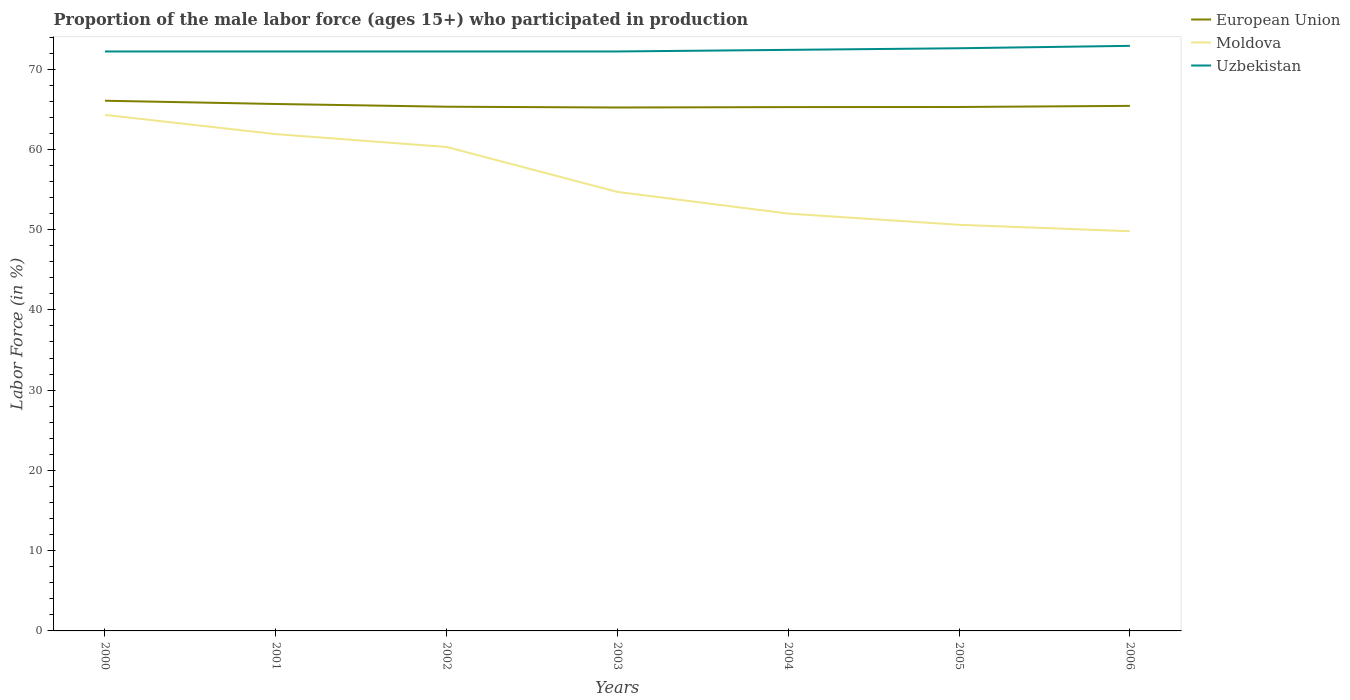How many different coloured lines are there?
Your answer should be very brief. 3. Does the line corresponding to European Union intersect with the line corresponding to Uzbekistan?
Ensure brevity in your answer.  No. Across all years, what is the maximum proportion of the male labor force who participated in production in Moldova?
Your answer should be very brief. 49.8. In which year was the proportion of the male labor force who participated in production in Moldova maximum?
Keep it short and to the point. 2006. What is the total proportion of the male labor force who participated in production in European Union in the graph?
Keep it short and to the point. 0.24. What is the difference between the highest and the second highest proportion of the male labor force who participated in production in Moldova?
Your response must be concise. 14.5. What is the difference between the highest and the lowest proportion of the male labor force who participated in production in Moldova?
Your response must be concise. 3. Is the proportion of the male labor force who participated in production in Moldova strictly greater than the proportion of the male labor force who participated in production in Uzbekistan over the years?
Offer a terse response. Yes. How many lines are there?
Keep it short and to the point. 3. Are the values on the major ticks of Y-axis written in scientific E-notation?
Offer a very short reply. No. Does the graph contain any zero values?
Your answer should be compact. No. How are the legend labels stacked?
Your answer should be compact. Vertical. What is the title of the graph?
Keep it short and to the point. Proportion of the male labor force (ages 15+) who participated in production. What is the Labor Force (in %) in European Union in 2000?
Your answer should be very brief. 66.06. What is the Labor Force (in %) in Moldova in 2000?
Offer a very short reply. 64.3. What is the Labor Force (in %) of Uzbekistan in 2000?
Provide a short and direct response. 72.2. What is the Labor Force (in %) of European Union in 2001?
Offer a terse response. 65.66. What is the Labor Force (in %) in Moldova in 2001?
Your answer should be very brief. 61.9. What is the Labor Force (in %) in Uzbekistan in 2001?
Your answer should be compact. 72.2. What is the Labor Force (in %) in European Union in 2002?
Make the answer very short. 65.31. What is the Labor Force (in %) in Moldova in 2002?
Your answer should be compact. 60.3. What is the Labor Force (in %) in Uzbekistan in 2002?
Ensure brevity in your answer.  72.2. What is the Labor Force (in %) in European Union in 2003?
Keep it short and to the point. 65.22. What is the Labor Force (in %) of Moldova in 2003?
Your answer should be very brief. 54.7. What is the Labor Force (in %) in Uzbekistan in 2003?
Provide a short and direct response. 72.2. What is the Labor Force (in %) of European Union in 2004?
Your answer should be very brief. 65.27. What is the Labor Force (in %) in Uzbekistan in 2004?
Keep it short and to the point. 72.4. What is the Labor Force (in %) of European Union in 2005?
Your answer should be compact. 65.28. What is the Labor Force (in %) in Moldova in 2005?
Your answer should be compact. 50.6. What is the Labor Force (in %) in Uzbekistan in 2005?
Give a very brief answer. 72.6. What is the Labor Force (in %) in European Union in 2006?
Make the answer very short. 65.42. What is the Labor Force (in %) in Moldova in 2006?
Make the answer very short. 49.8. What is the Labor Force (in %) in Uzbekistan in 2006?
Your answer should be very brief. 72.9. Across all years, what is the maximum Labor Force (in %) of European Union?
Give a very brief answer. 66.06. Across all years, what is the maximum Labor Force (in %) of Moldova?
Offer a terse response. 64.3. Across all years, what is the maximum Labor Force (in %) in Uzbekistan?
Give a very brief answer. 72.9. Across all years, what is the minimum Labor Force (in %) of European Union?
Keep it short and to the point. 65.22. Across all years, what is the minimum Labor Force (in %) in Moldova?
Give a very brief answer. 49.8. Across all years, what is the minimum Labor Force (in %) in Uzbekistan?
Your answer should be very brief. 72.2. What is the total Labor Force (in %) in European Union in the graph?
Offer a terse response. 458.22. What is the total Labor Force (in %) of Moldova in the graph?
Keep it short and to the point. 393.6. What is the total Labor Force (in %) in Uzbekistan in the graph?
Provide a short and direct response. 506.7. What is the difference between the Labor Force (in %) of European Union in 2000 and that in 2001?
Provide a succinct answer. 0.41. What is the difference between the Labor Force (in %) in Moldova in 2000 and that in 2001?
Offer a very short reply. 2.4. What is the difference between the Labor Force (in %) of Uzbekistan in 2000 and that in 2001?
Give a very brief answer. 0. What is the difference between the Labor Force (in %) of European Union in 2000 and that in 2002?
Provide a short and direct response. 0.75. What is the difference between the Labor Force (in %) in Uzbekistan in 2000 and that in 2002?
Provide a succinct answer. 0. What is the difference between the Labor Force (in %) in European Union in 2000 and that in 2003?
Your response must be concise. 0.84. What is the difference between the Labor Force (in %) in Uzbekistan in 2000 and that in 2003?
Give a very brief answer. 0. What is the difference between the Labor Force (in %) in European Union in 2000 and that in 2004?
Provide a succinct answer. 0.79. What is the difference between the Labor Force (in %) of European Union in 2000 and that in 2005?
Offer a terse response. 0.78. What is the difference between the Labor Force (in %) of Uzbekistan in 2000 and that in 2005?
Give a very brief answer. -0.4. What is the difference between the Labor Force (in %) of European Union in 2000 and that in 2006?
Give a very brief answer. 0.64. What is the difference between the Labor Force (in %) of Uzbekistan in 2000 and that in 2006?
Offer a terse response. -0.7. What is the difference between the Labor Force (in %) of European Union in 2001 and that in 2002?
Provide a succinct answer. 0.34. What is the difference between the Labor Force (in %) in Moldova in 2001 and that in 2002?
Provide a succinct answer. 1.6. What is the difference between the Labor Force (in %) in Uzbekistan in 2001 and that in 2002?
Offer a very short reply. 0. What is the difference between the Labor Force (in %) in European Union in 2001 and that in 2003?
Your response must be concise. 0.44. What is the difference between the Labor Force (in %) of Moldova in 2001 and that in 2003?
Provide a short and direct response. 7.2. What is the difference between the Labor Force (in %) in Uzbekistan in 2001 and that in 2003?
Ensure brevity in your answer.  0. What is the difference between the Labor Force (in %) of European Union in 2001 and that in 2004?
Ensure brevity in your answer.  0.39. What is the difference between the Labor Force (in %) of Moldova in 2001 and that in 2004?
Offer a terse response. 9.9. What is the difference between the Labor Force (in %) in Uzbekistan in 2001 and that in 2004?
Give a very brief answer. -0.2. What is the difference between the Labor Force (in %) in European Union in 2001 and that in 2005?
Provide a succinct answer. 0.37. What is the difference between the Labor Force (in %) of Uzbekistan in 2001 and that in 2005?
Keep it short and to the point. -0.4. What is the difference between the Labor Force (in %) of European Union in 2001 and that in 2006?
Offer a terse response. 0.24. What is the difference between the Labor Force (in %) of Moldova in 2001 and that in 2006?
Your answer should be very brief. 12.1. What is the difference between the Labor Force (in %) of Uzbekistan in 2001 and that in 2006?
Your answer should be very brief. -0.7. What is the difference between the Labor Force (in %) in European Union in 2002 and that in 2003?
Provide a succinct answer. 0.1. What is the difference between the Labor Force (in %) of Uzbekistan in 2002 and that in 2003?
Your response must be concise. 0. What is the difference between the Labor Force (in %) in European Union in 2002 and that in 2004?
Ensure brevity in your answer.  0.05. What is the difference between the Labor Force (in %) of Moldova in 2002 and that in 2004?
Make the answer very short. 8.3. What is the difference between the Labor Force (in %) in European Union in 2002 and that in 2005?
Offer a terse response. 0.03. What is the difference between the Labor Force (in %) of European Union in 2002 and that in 2006?
Your answer should be very brief. -0.1. What is the difference between the Labor Force (in %) of Moldova in 2002 and that in 2006?
Make the answer very short. 10.5. What is the difference between the Labor Force (in %) in European Union in 2003 and that in 2004?
Your answer should be very brief. -0.05. What is the difference between the Labor Force (in %) of Moldova in 2003 and that in 2004?
Give a very brief answer. 2.7. What is the difference between the Labor Force (in %) in Uzbekistan in 2003 and that in 2004?
Your response must be concise. -0.2. What is the difference between the Labor Force (in %) of European Union in 2003 and that in 2005?
Provide a succinct answer. -0.06. What is the difference between the Labor Force (in %) of Moldova in 2003 and that in 2005?
Your answer should be compact. 4.1. What is the difference between the Labor Force (in %) of Uzbekistan in 2003 and that in 2005?
Make the answer very short. -0.4. What is the difference between the Labor Force (in %) in European Union in 2003 and that in 2006?
Keep it short and to the point. -0.2. What is the difference between the Labor Force (in %) in European Union in 2004 and that in 2005?
Offer a very short reply. -0.01. What is the difference between the Labor Force (in %) in European Union in 2004 and that in 2006?
Keep it short and to the point. -0.15. What is the difference between the Labor Force (in %) of Moldova in 2004 and that in 2006?
Make the answer very short. 2.2. What is the difference between the Labor Force (in %) of European Union in 2005 and that in 2006?
Your answer should be compact. -0.14. What is the difference between the Labor Force (in %) in Moldova in 2005 and that in 2006?
Your response must be concise. 0.8. What is the difference between the Labor Force (in %) of Uzbekistan in 2005 and that in 2006?
Offer a very short reply. -0.3. What is the difference between the Labor Force (in %) in European Union in 2000 and the Labor Force (in %) in Moldova in 2001?
Give a very brief answer. 4.16. What is the difference between the Labor Force (in %) in European Union in 2000 and the Labor Force (in %) in Uzbekistan in 2001?
Provide a short and direct response. -6.14. What is the difference between the Labor Force (in %) in European Union in 2000 and the Labor Force (in %) in Moldova in 2002?
Provide a short and direct response. 5.76. What is the difference between the Labor Force (in %) of European Union in 2000 and the Labor Force (in %) of Uzbekistan in 2002?
Your response must be concise. -6.14. What is the difference between the Labor Force (in %) of Moldova in 2000 and the Labor Force (in %) of Uzbekistan in 2002?
Provide a succinct answer. -7.9. What is the difference between the Labor Force (in %) in European Union in 2000 and the Labor Force (in %) in Moldova in 2003?
Your response must be concise. 11.36. What is the difference between the Labor Force (in %) in European Union in 2000 and the Labor Force (in %) in Uzbekistan in 2003?
Your answer should be very brief. -6.14. What is the difference between the Labor Force (in %) in Moldova in 2000 and the Labor Force (in %) in Uzbekistan in 2003?
Offer a terse response. -7.9. What is the difference between the Labor Force (in %) in European Union in 2000 and the Labor Force (in %) in Moldova in 2004?
Your response must be concise. 14.06. What is the difference between the Labor Force (in %) of European Union in 2000 and the Labor Force (in %) of Uzbekistan in 2004?
Your answer should be very brief. -6.34. What is the difference between the Labor Force (in %) of Moldova in 2000 and the Labor Force (in %) of Uzbekistan in 2004?
Offer a very short reply. -8.1. What is the difference between the Labor Force (in %) of European Union in 2000 and the Labor Force (in %) of Moldova in 2005?
Your response must be concise. 15.46. What is the difference between the Labor Force (in %) of European Union in 2000 and the Labor Force (in %) of Uzbekistan in 2005?
Give a very brief answer. -6.54. What is the difference between the Labor Force (in %) of Moldova in 2000 and the Labor Force (in %) of Uzbekistan in 2005?
Give a very brief answer. -8.3. What is the difference between the Labor Force (in %) of European Union in 2000 and the Labor Force (in %) of Moldova in 2006?
Give a very brief answer. 16.26. What is the difference between the Labor Force (in %) in European Union in 2000 and the Labor Force (in %) in Uzbekistan in 2006?
Make the answer very short. -6.84. What is the difference between the Labor Force (in %) in Moldova in 2000 and the Labor Force (in %) in Uzbekistan in 2006?
Provide a succinct answer. -8.6. What is the difference between the Labor Force (in %) of European Union in 2001 and the Labor Force (in %) of Moldova in 2002?
Give a very brief answer. 5.36. What is the difference between the Labor Force (in %) in European Union in 2001 and the Labor Force (in %) in Uzbekistan in 2002?
Your response must be concise. -6.54. What is the difference between the Labor Force (in %) in Moldova in 2001 and the Labor Force (in %) in Uzbekistan in 2002?
Offer a terse response. -10.3. What is the difference between the Labor Force (in %) in European Union in 2001 and the Labor Force (in %) in Moldova in 2003?
Your response must be concise. 10.96. What is the difference between the Labor Force (in %) of European Union in 2001 and the Labor Force (in %) of Uzbekistan in 2003?
Offer a very short reply. -6.54. What is the difference between the Labor Force (in %) in European Union in 2001 and the Labor Force (in %) in Moldova in 2004?
Your response must be concise. 13.66. What is the difference between the Labor Force (in %) of European Union in 2001 and the Labor Force (in %) of Uzbekistan in 2004?
Your answer should be very brief. -6.74. What is the difference between the Labor Force (in %) in European Union in 2001 and the Labor Force (in %) in Moldova in 2005?
Offer a very short reply. 15.06. What is the difference between the Labor Force (in %) of European Union in 2001 and the Labor Force (in %) of Uzbekistan in 2005?
Offer a very short reply. -6.94. What is the difference between the Labor Force (in %) of European Union in 2001 and the Labor Force (in %) of Moldova in 2006?
Your answer should be very brief. 15.86. What is the difference between the Labor Force (in %) of European Union in 2001 and the Labor Force (in %) of Uzbekistan in 2006?
Ensure brevity in your answer.  -7.24. What is the difference between the Labor Force (in %) of European Union in 2002 and the Labor Force (in %) of Moldova in 2003?
Provide a succinct answer. 10.61. What is the difference between the Labor Force (in %) in European Union in 2002 and the Labor Force (in %) in Uzbekistan in 2003?
Your answer should be very brief. -6.89. What is the difference between the Labor Force (in %) in Moldova in 2002 and the Labor Force (in %) in Uzbekistan in 2003?
Offer a very short reply. -11.9. What is the difference between the Labor Force (in %) in European Union in 2002 and the Labor Force (in %) in Moldova in 2004?
Your answer should be very brief. 13.31. What is the difference between the Labor Force (in %) of European Union in 2002 and the Labor Force (in %) of Uzbekistan in 2004?
Provide a succinct answer. -7.09. What is the difference between the Labor Force (in %) of European Union in 2002 and the Labor Force (in %) of Moldova in 2005?
Provide a short and direct response. 14.71. What is the difference between the Labor Force (in %) of European Union in 2002 and the Labor Force (in %) of Uzbekistan in 2005?
Your response must be concise. -7.29. What is the difference between the Labor Force (in %) in Moldova in 2002 and the Labor Force (in %) in Uzbekistan in 2005?
Make the answer very short. -12.3. What is the difference between the Labor Force (in %) of European Union in 2002 and the Labor Force (in %) of Moldova in 2006?
Your response must be concise. 15.51. What is the difference between the Labor Force (in %) in European Union in 2002 and the Labor Force (in %) in Uzbekistan in 2006?
Provide a succinct answer. -7.59. What is the difference between the Labor Force (in %) in European Union in 2003 and the Labor Force (in %) in Moldova in 2004?
Your response must be concise. 13.22. What is the difference between the Labor Force (in %) of European Union in 2003 and the Labor Force (in %) of Uzbekistan in 2004?
Your answer should be very brief. -7.18. What is the difference between the Labor Force (in %) of Moldova in 2003 and the Labor Force (in %) of Uzbekistan in 2004?
Your response must be concise. -17.7. What is the difference between the Labor Force (in %) of European Union in 2003 and the Labor Force (in %) of Moldova in 2005?
Your answer should be compact. 14.62. What is the difference between the Labor Force (in %) of European Union in 2003 and the Labor Force (in %) of Uzbekistan in 2005?
Keep it short and to the point. -7.38. What is the difference between the Labor Force (in %) in Moldova in 2003 and the Labor Force (in %) in Uzbekistan in 2005?
Your answer should be compact. -17.9. What is the difference between the Labor Force (in %) of European Union in 2003 and the Labor Force (in %) of Moldova in 2006?
Offer a very short reply. 15.42. What is the difference between the Labor Force (in %) in European Union in 2003 and the Labor Force (in %) in Uzbekistan in 2006?
Keep it short and to the point. -7.68. What is the difference between the Labor Force (in %) of Moldova in 2003 and the Labor Force (in %) of Uzbekistan in 2006?
Your response must be concise. -18.2. What is the difference between the Labor Force (in %) of European Union in 2004 and the Labor Force (in %) of Moldova in 2005?
Make the answer very short. 14.67. What is the difference between the Labor Force (in %) in European Union in 2004 and the Labor Force (in %) in Uzbekistan in 2005?
Give a very brief answer. -7.33. What is the difference between the Labor Force (in %) of Moldova in 2004 and the Labor Force (in %) of Uzbekistan in 2005?
Your answer should be compact. -20.6. What is the difference between the Labor Force (in %) in European Union in 2004 and the Labor Force (in %) in Moldova in 2006?
Make the answer very short. 15.47. What is the difference between the Labor Force (in %) of European Union in 2004 and the Labor Force (in %) of Uzbekistan in 2006?
Your answer should be very brief. -7.63. What is the difference between the Labor Force (in %) of Moldova in 2004 and the Labor Force (in %) of Uzbekistan in 2006?
Make the answer very short. -20.9. What is the difference between the Labor Force (in %) of European Union in 2005 and the Labor Force (in %) of Moldova in 2006?
Your response must be concise. 15.48. What is the difference between the Labor Force (in %) in European Union in 2005 and the Labor Force (in %) in Uzbekistan in 2006?
Ensure brevity in your answer.  -7.62. What is the difference between the Labor Force (in %) in Moldova in 2005 and the Labor Force (in %) in Uzbekistan in 2006?
Your answer should be very brief. -22.3. What is the average Labor Force (in %) in European Union per year?
Offer a terse response. 65.46. What is the average Labor Force (in %) in Moldova per year?
Your answer should be compact. 56.23. What is the average Labor Force (in %) in Uzbekistan per year?
Ensure brevity in your answer.  72.39. In the year 2000, what is the difference between the Labor Force (in %) in European Union and Labor Force (in %) in Moldova?
Make the answer very short. 1.76. In the year 2000, what is the difference between the Labor Force (in %) of European Union and Labor Force (in %) of Uzbekistan?
Give a very brief answer. -6.14. In the year 2001, what is the difference between the Labor Force (in %) of European Union and Labor Force (in %) of Moldova?
Offer a terse response. 3.76. In the year 2001, what is the difference between the Labor Force (in %) in European Union and Labor Force (in %) in Uzbekistan?
Ensure brevity in your answer.  -6.54. In the year 2001, what is the difference between the Labor Force (in %) of Moldova and Labor Force (in %) of Uzbekistan?
Your answer should be very brief. -10.3. In the year 2002, what is the difference between the Labor Force (in %) in European Union and Labor Force (in %) in Moldova?
Offer a terse response. 5.01. In the year 2002, what is the difference between the Labor Force (in %) of European Union and Labor Force (in %) of Uzbekistan?
Your answer should be compact. -6.89. In the year 2002, what is the difference between the Labor Force (in %) in Moldova and Labor Force (in %) in Uzbekistan?
Offer a very short reply. -11.9. In the year 2003, what is the difference between the Labor Force (in %) in European Union and Labor Force (in %) in Moldova?
Keep it short and to the point. 10.52. In the year 2003, what is the difference between the Labor Force (in %) in European Union and Labor Force (in %) in Uzbekistan?
Provide a short and direct response. -6.98. In the year 2003, what is the difference between the Labor Force (in %) in Moldova and Labor Force (in %) in Uzbekistan?
Offer a very short reply. -17.5. In the year 2004, what is the difference between the Labor Force (in %) in European Union and Labor Force (in %) in Moldova?
Your answer should be compact. 13.27. In the year 2004, what is the difference between the Labor Force (in %) in European Union and Labor Force (in %) in Uzbekistan?
Your answer should be compact. -7.13. In the year 2004, what is the difference between the Labor Force (in %) in Moldova and Labor Force (in %) in Uzbekistan?
Make the answer very short. -20.4. In the year 2005, what is the difference between the Labor Force (in %) of European Union and Labor Force (in %) of Moldova?
Your answer should be compact. 14.68. In the year 2005, what is the difference between the Labor Force (in %) of European Union and Labor Force (in %) of Uzbekistan?
Your response must be concise. -7.32. In the year 2005, what is the difference between the Labor Force (in %) in Moldova and Labor Force (in %) in Uzbekistan?
Offer a terse response. -22. In the year 2006, what is the difference between the Labor Force (in %) in European Union and Labor Force (in %) in Moldova?
Your answer should be very brief. 15.62. In the year 2006, what is the difference between the Labor Force (in %) of European Union and Labor Force (in %) of Uzbekistan?
Your answer should be very brief. -7.48. In the year 2006, what is the difference between the Labor Force (in %) in Moldova and Labor Force (in %) in Uzbekistan?
Make the answer very short. -23.1. What is the ratio of the Labor Force (in %) of Moldova in 2000 to that in 2001?
Give a very brief answer. 1.04. What is the ratio of the Labor Force (in %) in Uzbekistan in 2000 to that in 2001?
Your response must be concise. 1. What is the ratio of the Labor Force (in %) of European Union in 2000 to that in 2002?
Your response must be concise. 1.01. What is the ratio of the Labor Force (in %) in Moldova in 2000 to that in 2002?
Offer a very short reply. 1.07. What is the ratio of the Labor Force (in %) in Uzbekistan in 2000 to that in 2002?
Make the answer very short. 1. What is the ratio of the Labor Force (in %) in European Union in 2000 to that in 2003?
Provide a short and direct response. 1.01. What is the ratio of the Labor Force (in %) in Moldova in 2000 to that in 2003?
Your answer should be compact. 1.18. What is the ratio of the Labor Force (in %) of European Union in 2000 to that in 2004?
Offer a terse response. 1.01. What is the ratio of the Labor Force (in %) of Moldova in 2000 to that in 2004?
Your answer should be very brief. 1.24. What is the ratio of the Labor Force (in %) in Uzbekistan in 2000 to that in 2004?
Offer a very short reply. 1. What is the ratio of the Labor Force (in %) in European Union in 2000 to that in 2005?
Provide a succinct answer. 1.01. What is the ratio of the Labor Force (in %) of Moldova in 2000 to that in 2005?
Offer a very short reply. 1.27. What is the ratio of the Labor Force (in %) of Uzbekistan in 2000 to that in 2005?
Offer a very short reply. 0.99. What is the ratio of the Labor Force (in %) of European Union in 2000 to that in 2006?
Your answer should be very brief. 1.01. What is the ratio of the Labor Force (in %) in Moldova in 2000 to that in 2006?
Offer a very short reply. 1.29. What is the ratio of the Labor Force (in %) of Uzbekistan in 2000 to that in 2006?
Your response must be concise. 0.99. What is the ratio of the Labor Force (in %) in European Union in 2001 to that in 2002?
Give a very brief answer. 1.01. What is the ratio of the Labor Force (in %) of Moldova in 2001 to that in 2002?
Offer a very short reply. 1.03. What is the ratio of the Labor Force (in %) of Uzbekistan in 2001 to that in 2002?
Your answer should be compact. 1. What is the ratio of the Labor Force (in %) of European Union in 2001 to that in 2003?
Provide a succinct answer. 1.01. What is the ratio of the Labor Force (in %) of Moldova in 2001 to that in 2003?
Provide a succinct answer. 1.13. What is the ratio of the Labor Force (in %) in Uzbekistan in 2001 to that in 2003?
Your answer should be very brief. 1. What is the ratio of the Labor Force (in %) in European Union in 2001 to that in 2004?
Your answer should be very brief. 1.01. What is the ratio of the Labor Force (in %) of Moldova in 2001 to that in 2004?
Provide a short and direct response. 1.19. What is the ratio of the Labor Force (in %) in Moldova in 2001 to that in 2005?
Give a very brief answer. 1.22. What is the ratio of the Labor Force (in %) in Moldova in 2001 to that in 2006?
Offer a terse response. 1.24. What is the ratio of the Labor Force (in %) of European Union in 2002 to that in 2003?
Provide a succinct answer. 1. What is the ratio of the Labor Force (in %) in Moldova in 2002 to that in 2003?
Ensure brevity in your answer.  1.1. What is the ratio of the Labor Force (in %) of Uzbekistan in 2002 to that in 2003?
Provide a succinct answer. 1. What is the ratio of the Labor Force (in %) in European Union in 2002 to that in 2004?
Your answer should be very brief. 1. What is the ratio of the Labor Force (in %) in Moldova in 2002 to that in 2004?
Give a very brief answer. 1.16. What is the ratio of the Labor Force (in %) of Uzbekistan in 2002 to that in 2004?
Make the answer very short. 1. What is the ratio of the Labor Force (in %) in Moldova in 2002 to that in 2005?
Offer a terse response. 1.19. What is the ratio of the Labor Force (in %) in Uzbekistan in 2002 to that in 2005?
Ensure brevity in your answer.  0.99. What is the ratio of the Labor Force (in %) of European Union in 2002 to that in 2006?
Keep it short and to the point. 1. What is the ratio of the Labor Force (in %) in Moldova in 2002 to that in 2006?
Keep it short and to the point. 1.21. What is the ratio of the Labor Force (in %) in European Union in 2003 to that in 2004?
Your answer should be very brief. 1. What is the ratio of the Labor Force (in %) of Moldova in 2003 to that in 2004?
Ensure brevity in your answer.  1.05. What is the ratio of the Labor Force (in %) of Uzbekistan in 2003 to that in 2004?
Offer a very short reply. 1. What is the ratio of the Labor Force (in %) of Moldova in 2003 to that in 2005?
Ensure brevity in your answer.  1.08. What is the ratio of the Labor Force (in %) of Moldova in 2003 to that in 2006?
Offer a terse response. 1.1. What is the ratio of the Labor Force (in %) in Uzbekistan in 2003 to that in 2006?
Ensure brevity in your answer.  0.99. What is the ratio of the Labor Force (in %) of Moldova in 2004 to that in 2005?
Make the answer very short. 1.03. What is the ratio of the Labor Force (in %) of Moldova in 2004 to that in 2006?
Your response must be concise. 1.04. What is the ratio of the Labor Force (in %) of Uzbekistan in 2004 to that in 2006?
Ensure brevity in your answer.  0.99. What is the ratio of the Labor Force (in %) of Moldova in 2005 to that in 2006?
Provide a succinct answer. 1.02. What is the difference between the highest and the second highest Labor Force (in %) in European Union?
Make the answer very short. 0.41. What is the difference between the highest and the second highest Labor Force (in %) of Moldova?
Your answer should be compact. 2.4. What is the difference between the highest and the second highest Labor Force (in %) of Uzbekistan?
Your answer should be compact. 0.3. What is the difference between the highest and the lowest Labor Force (in %) in European Union?
Make the answer very short. 0.84. What is the difference between the highest and the lowest Labor Force (in %) in Moldova?
Your answer should be compact. 14.5. 